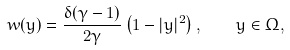Convert formula to latex. <formula><loc_0><loc_0><loc_500><loc_500>w ( y ) = \frac { \delta ( \gamma - 1 ) } { 2 \gamma } \left ( 1 - | y | ^ { 2 } \right ) , \quad y \in \Omega ,</formula> 